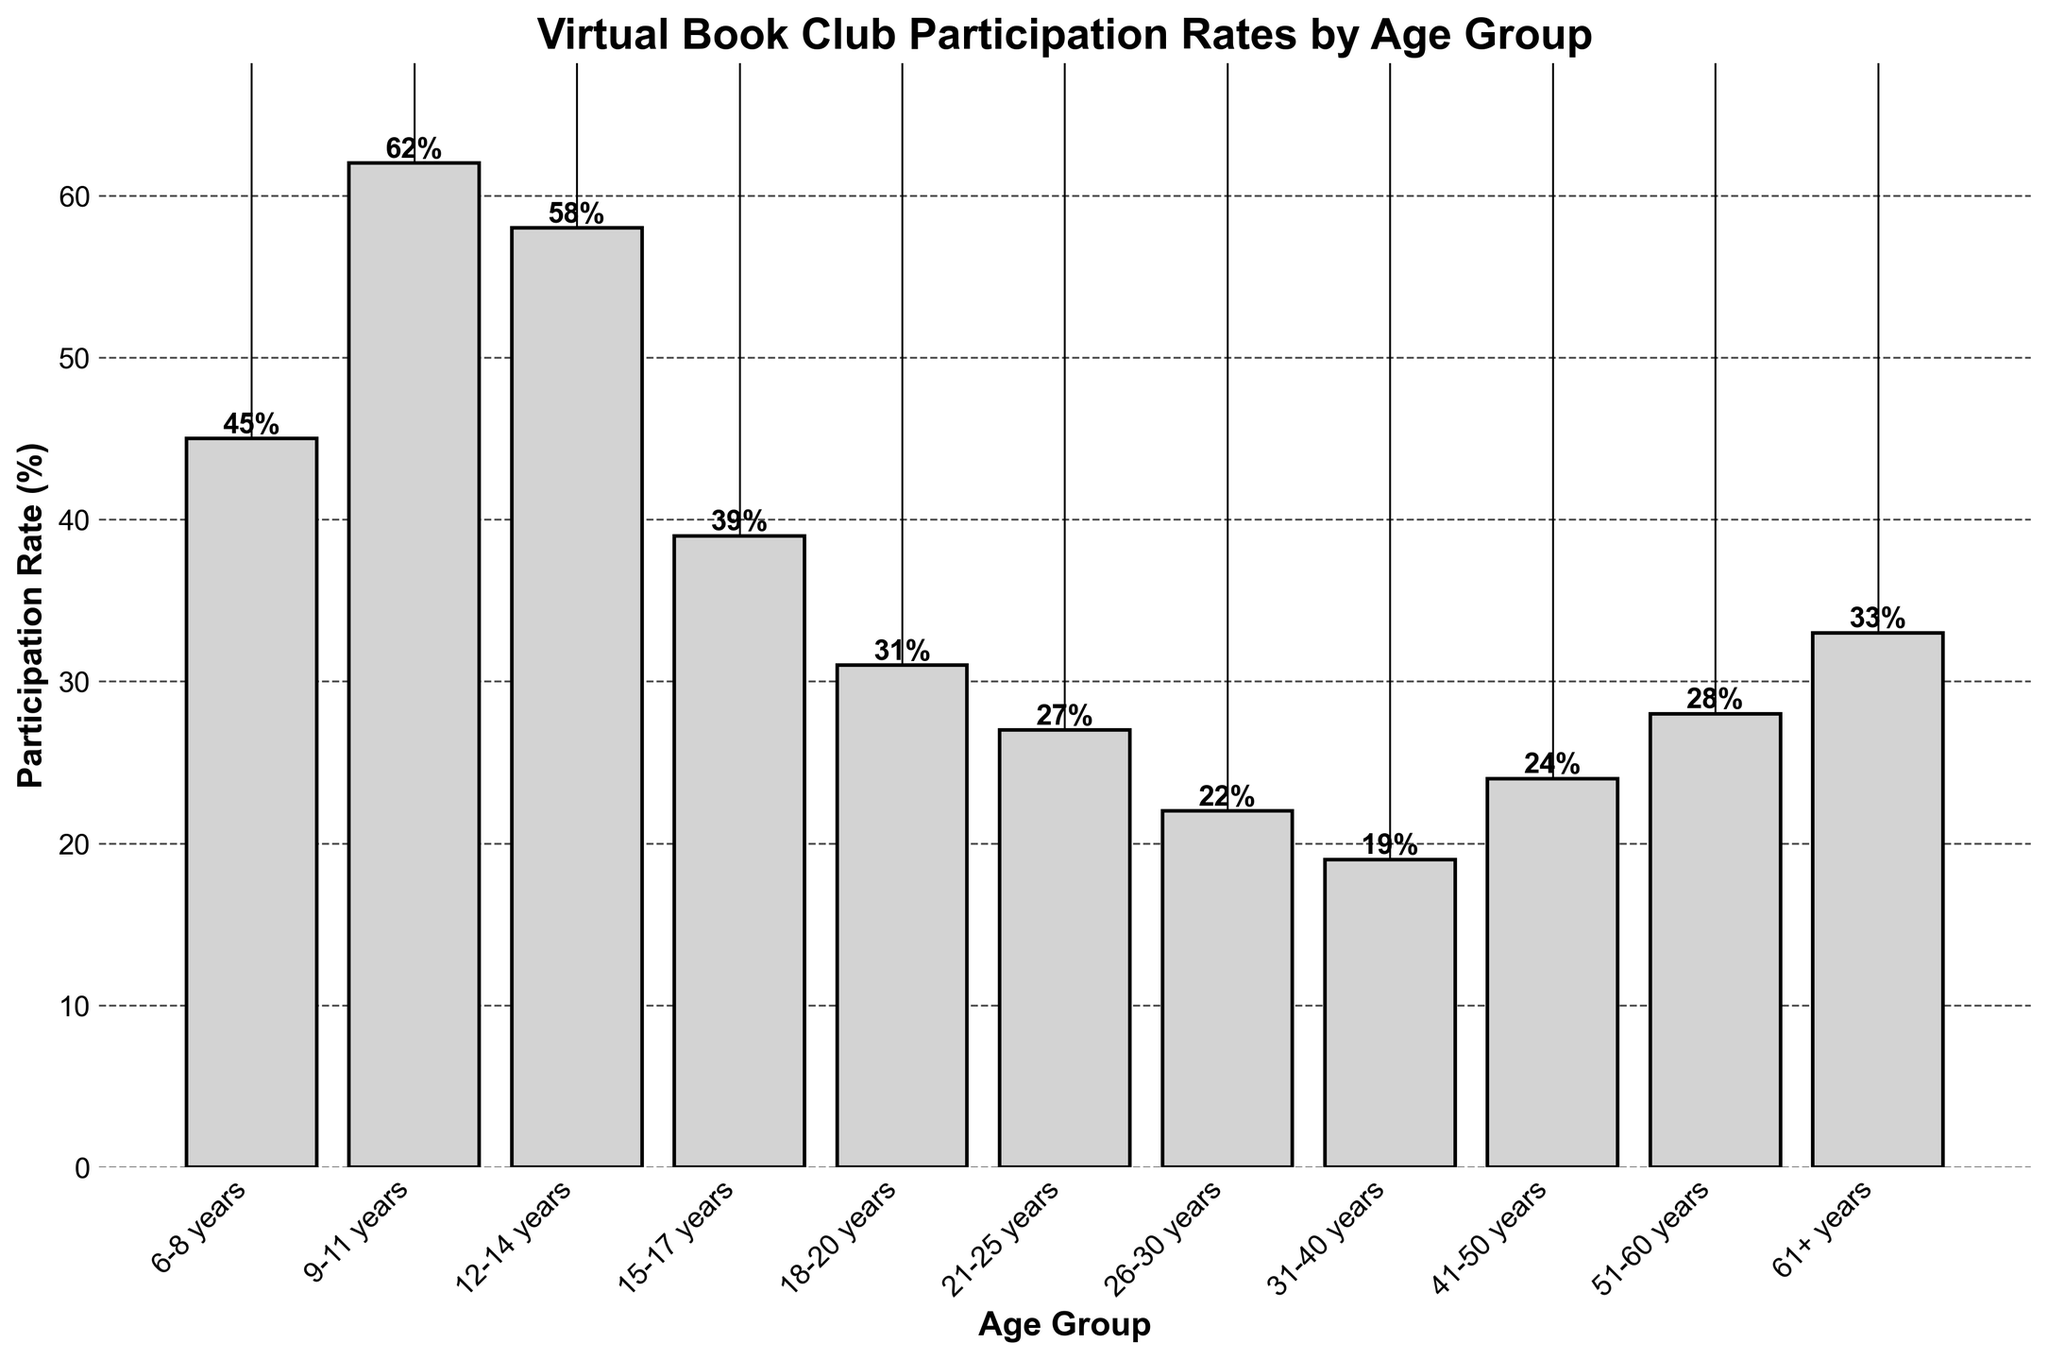What is the age group with the highest participation rate in virtual book clubs? The bar for the 9-11 years age group is the tallest, indicating the highest participation rate at 62%.
Answer: 9-11 years What is the difference in participation rate between the 6-8 years group and the 12-14 years group? The participation rate for 6-8 years is 45%, while for 12-14 years it is 58%. The difference is 58% - 45% = 13%.
Answer: 13% Which age group has the lowest participation rate in virtual book clubs? The bar for the 31-40 years age group is the shortest, with a participation rate of 19%.
Answer: 31-40 years How many age groups have a participation rate of over 30%? The age groups with participation rates over 30% are: 6-8 years, 9-11 years, 12-14 years, 15-17 years, 18-20 years, and 61+ years. This totals to 6 age groups.
Answer: 6 What is the average participation rate of the age groups between 21-30 years? The rates for the 21-25 years and 26-30 years groups are 27% and 22% respectively. The average is (27% + 22%) / 2 = 24.5%.
Answer: 24.5% Which age group has a higher participation rate, 51-60 years or 61+ years? The participation rate for the 51-60 years group is 28%, while for the 61+ years group it is 33%. The 61+ years group has a higher rate.
Answer: 61+ years What is the total participation rate for the age groups between 41-60 years? The rates for the 41-50 years and 51-60 years groups are 24% and 28% respectively. The total is 24% + 28% = 52%.
Answer: 52% Which age groups have a participation rate higher than the average participation rate? The average participation rate is calculated as the mean of all rates ((45+62+58+39+31+27+22+19+24+28+33)/11 = ~35.45%). The age groups with rates higher than this average are 6-8 years, 9-11 years, and 12-14 years.
Answer: 6-8 years, 9-11 years, 12-14 years 